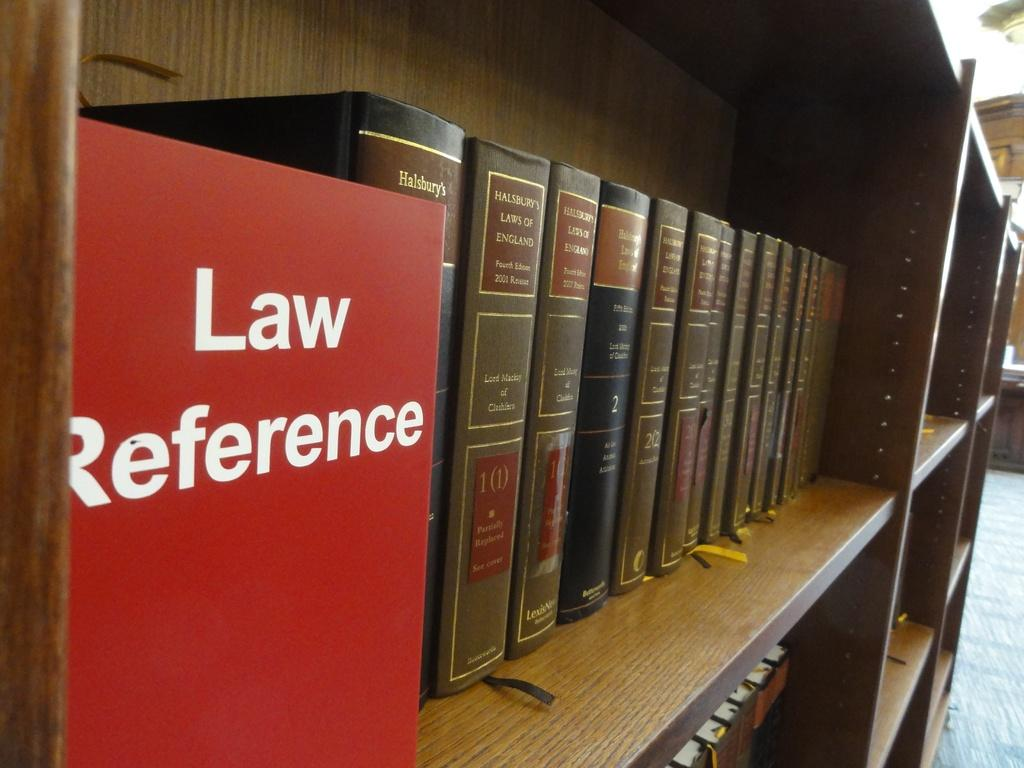What can be seen on the rack in the image? There is a rack containing books in the image. What is located on the left side of the image? There is a board on the left side of the image. Where is the key placed on the board in the image? There is no key present on the board in the image. What type of trousers are hanging on the rack with the books? There are no trousers present on the rack with the books; only books are visible. 